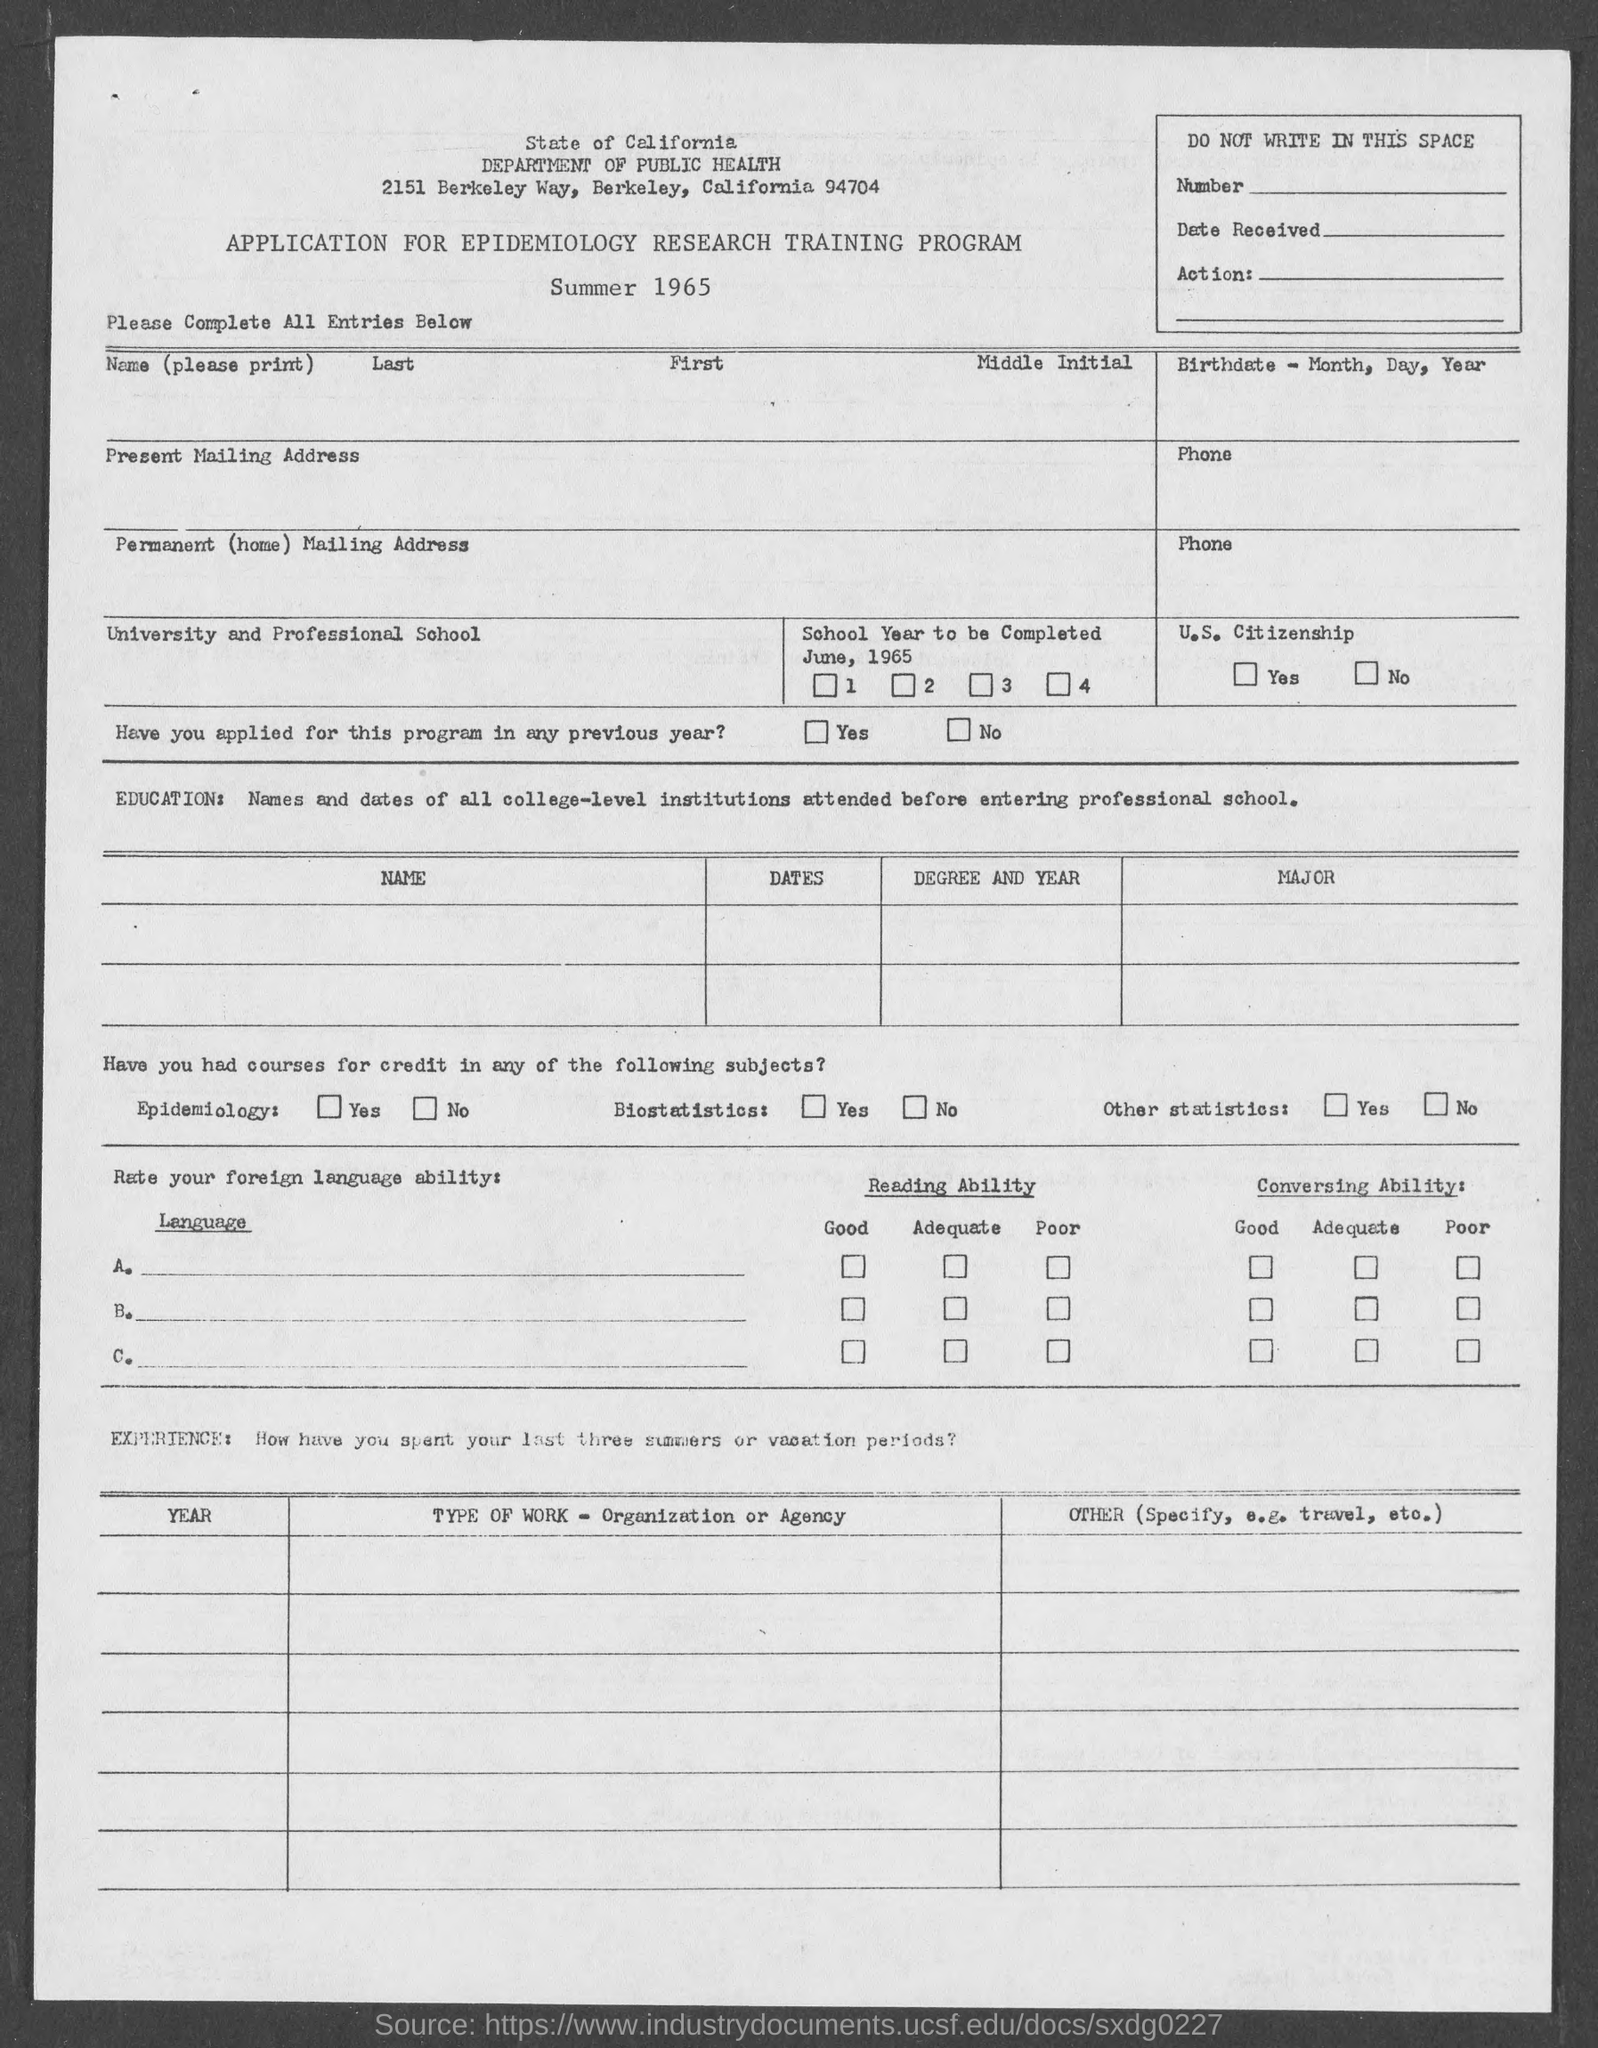In which city is state of california department of public health at ?
Ensure brevity in your answer.  Berkeley. 